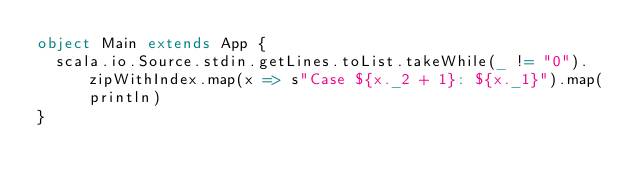<code> <loc_0><loc_0><loc_500><loc_500><_Scala_>object Main extends App {
  scala.io.Source.stdin.getLines.toList.takeWhile(_ != "0").zipWithIndex.map(x => s"Case ${x._2 + 1}: ${x._1}").map(println)
}</code> 